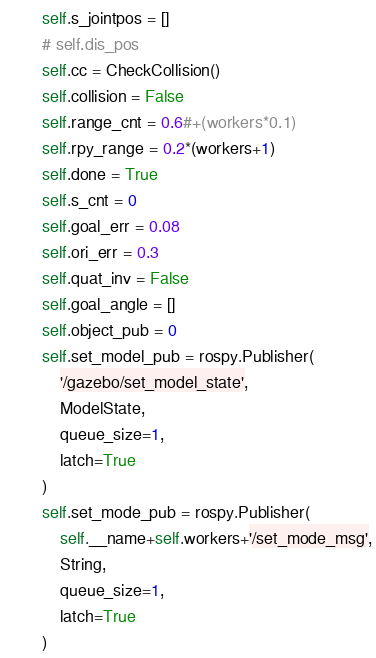<code> <loc_0><loc_0><loc_500><loc_500><_Python_>        self.s_jointpos = []
        # self.dis_pos
        self.cc = CheckCollision()
        self.collision = False
        self.range_cnt = 0.6#+(workers*0.1)
        self.rpy_range = 0.2*(workers+1)
        self.done = True
        self.s_cnt = 0
        self.goal_err = 0.08
        self.ori_err = 0.3
        self.quat_inv = False
        self.goal_angle = []
        self.object_pub = 0
        self.set_model_pub = rospy.Publisher(
            '/gazebo/set_model_state',
            ModelState,
            queue_size=1,
            latch=True
        )
        self.set_mode_pub = rospy.Publisher(
            self.__name+self.workers+'/set_mode_msg',
            String,
            queue_size=1,
            latch=True
        )
</code> 